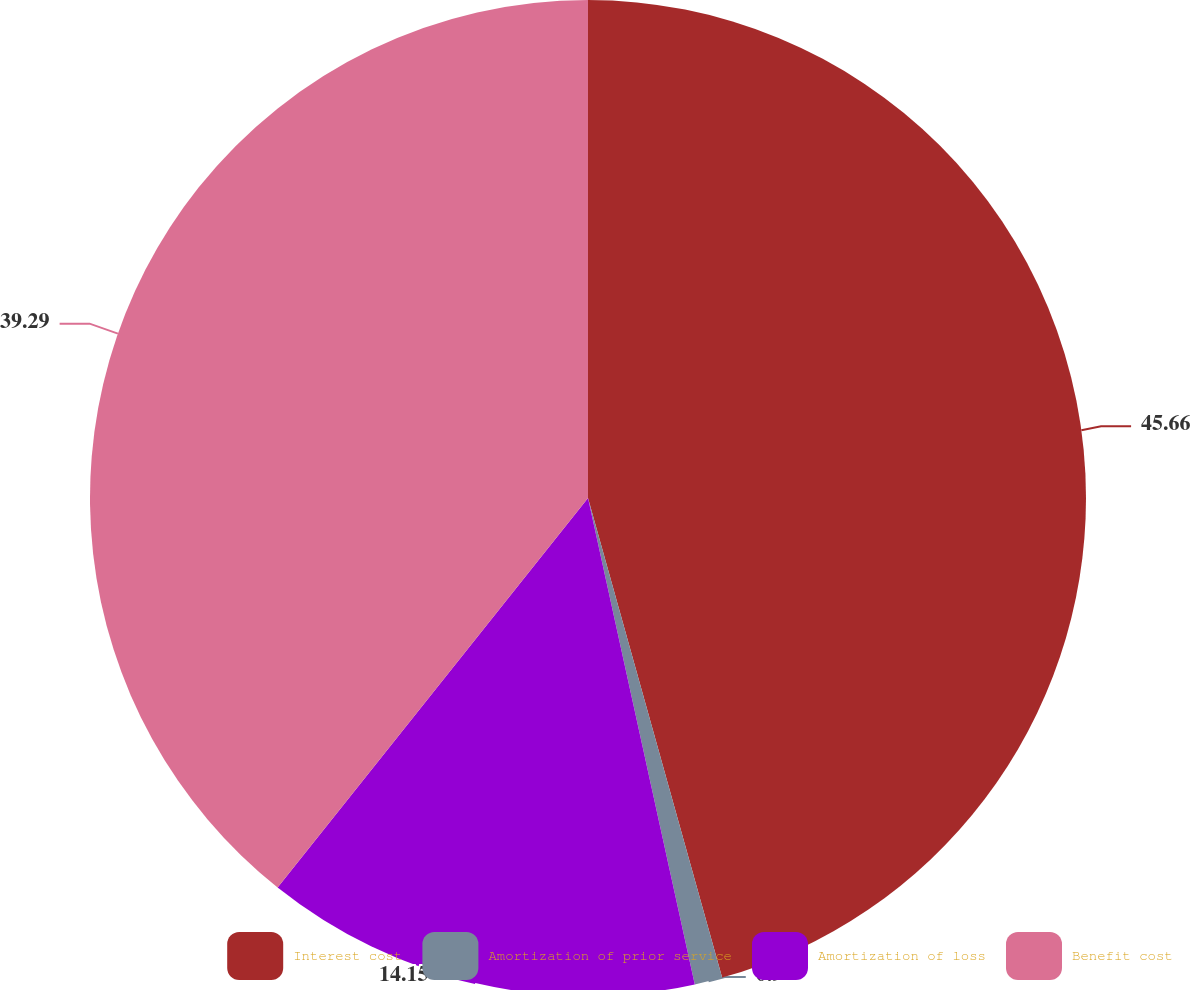Convert chart to OTSL. <chart><loc_0><loc_0><loc_500><loc_500><pie_chart><fcel>Interest cost<fcel>Amortization of prior service<fcel>Amortization of loss<fcel>Benefit cost<nl><fcel>45.66%<fcel>0.9%<fcel>14.15%<fcel>39.29%<nl></chart> 